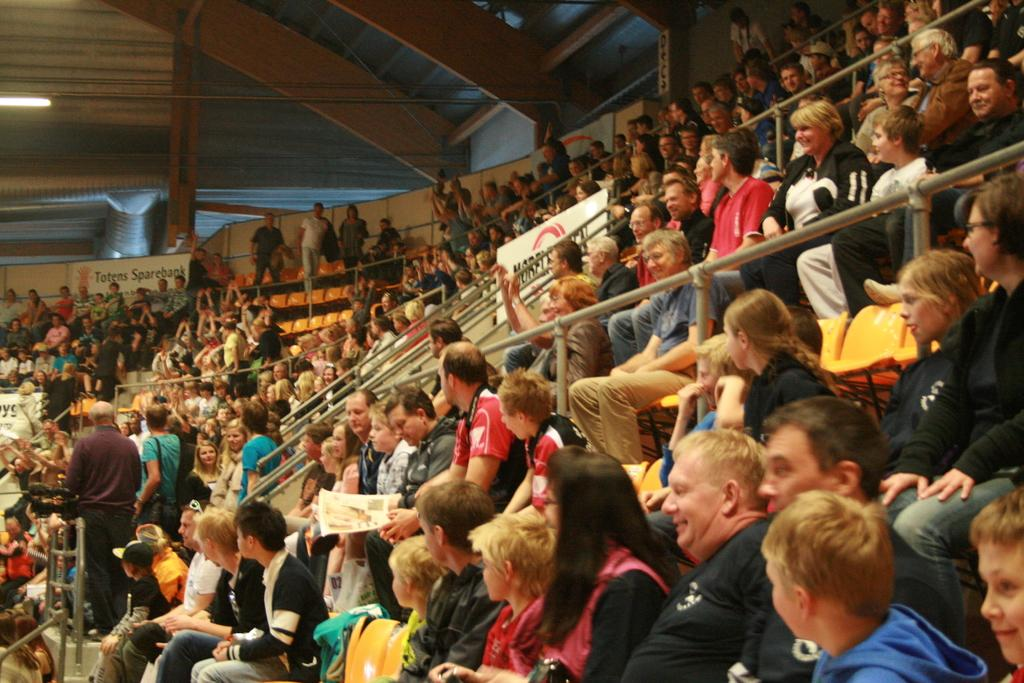How many people are in the image? There are many people in the image. What are the people doing in the image? The people are sitting on chairs and looking at a game. Where was the image taken? The image was taken inside an auditorium. What can be seen on the ceiling in the image? There are lights on the ceiling. What type of magic trick is being performed by the people's feet in the image? There is no magic trick being performed by the people's feet in the image, as the people are sitting on chairs and looking at a game. Is there a van visible in the image? No, there is no van present in the image. 